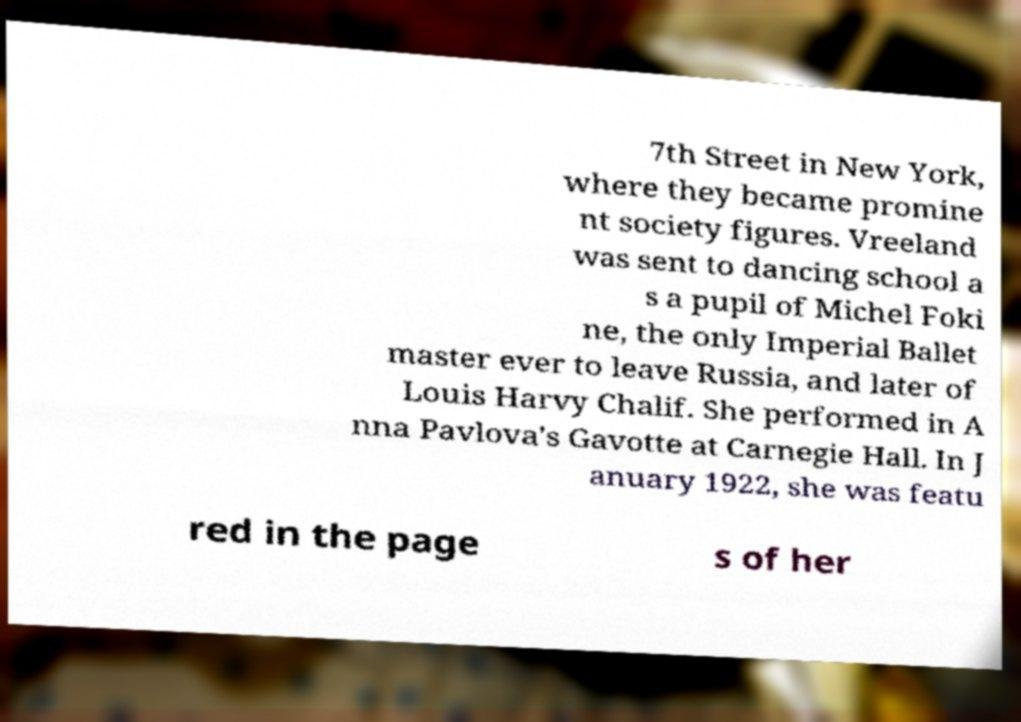There's text embedded in this image that I need extracted. Can you transcribe it verbatim? 7th Street in New York, where they became promine nt society figures. Vreeland was sent to dancing school a s a pupil of Michel Foki ne, the only Imperial Ballet master ever to leave Russia, and later of Louis Harvy Chalif. She performed in A nna Pavlova's Gavotte at Carnegie Hall. In J anuary 1922, she was featu red in the page s of her 